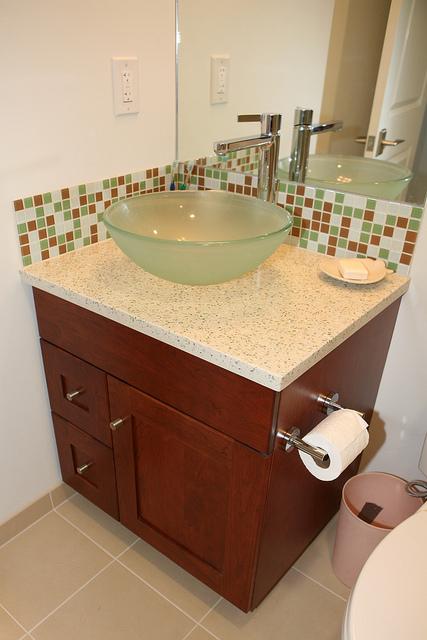Is the bathroom door open?
Write a very short answer. Yes. How many colors are in the tile?
Short answer required. 3. What color is the bowl?
Quick response, please. Green. 